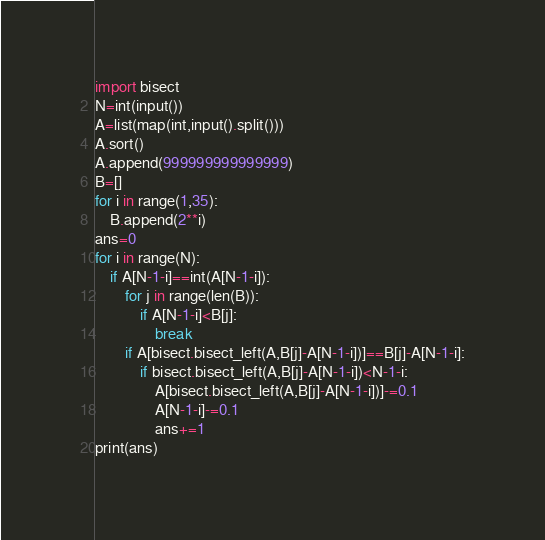Convert code to text. <code><loc_0><loc_0><loc_500><loc_500><_Python_>import bisect
N=int(input())
A=list(map(int,input().split()))
A.sort()
A.append(999999999999999)
B=[]
for i in range(1,35):
    B.append(2**i)
ans=0
for i in range(N):
    if A[N-1-i]==int(A[N-1-i]):
        for j in range(len(B)):
            if A[N-1-i]<B[j]:
                break
        if A[bisect.bisect_left(A,B[j]-A[N-1-i])]==B[j]-A[N-1-i]:
            if bisect.bisect_left(A,B[j]-A[N-1-i])<N-1-i:
                A[bisect.bisect_left(A,B[j]-A[N-1-i])]-=0.1
                A[N-1-i]-=0.1
                ans+=1
print(ans)</code> 